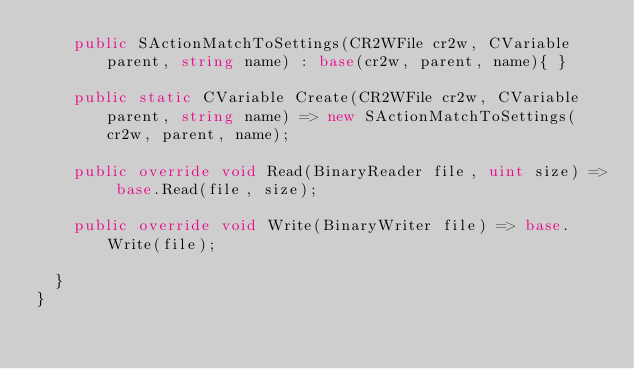<code> <loc_0><loc_0><loc_500><loc_500><_C#_>		public SActionMatchToSettings(CR2WFile cr2w, CVariable parent, string name) : base(cr2w, parent, name){ }

		public static CVariable Create(CR2WFile cr2w, CVariable parent, string name) => new SActionMatchToSettings(cr2w, parent, name);

		public override void Read(BinaryReader file, uint size) => base.Read(file, size);

		public override void Write(BinaryWriter file) => base.Write(file);

	}
}</code> 